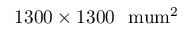<formula> <loc_0><loc_0><loc_500><loc_500>1 3 0 0 \times 1 3 0 0 \ \ m u m ^ { 2 }</formula> 